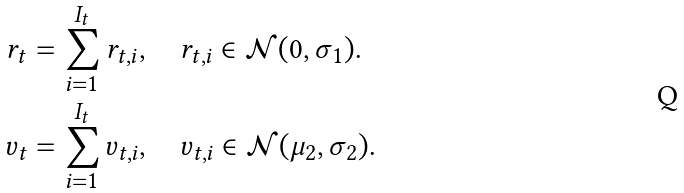Convert formula to latex. <formula><loc_0><loc_0><loc_500><loc_500>r _ { t } & = \sum _ { i = 1 } ^ { I _ { t } } r _ { t , i } , \quad r _ { t , i } \in \mathcal { N } ( 0 , \sigma _ { 1 } ) . \\ v _ { t } & = \sum _ { i = 1 } ^ { I _ { t } } v _ { t , i } , \quad v _ { t , i } \in \mathcal { N } ( \mu _ { 2 } , \sigma _ { 2 } ) .</formula> 